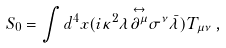Convert formula to latex. <formula><loc_0><loc_0><loc_500><loc_500>S _ { 0 } = \int d ^ { 4 } x ( i \kappa ^ { 2 } \lambda \overset { \leftrightarrow } { \partial ^ { \mu } } \sigma ^ { \nu } \bar { \lambda } ) T _ { \mu \nu } \, ,</formula> 